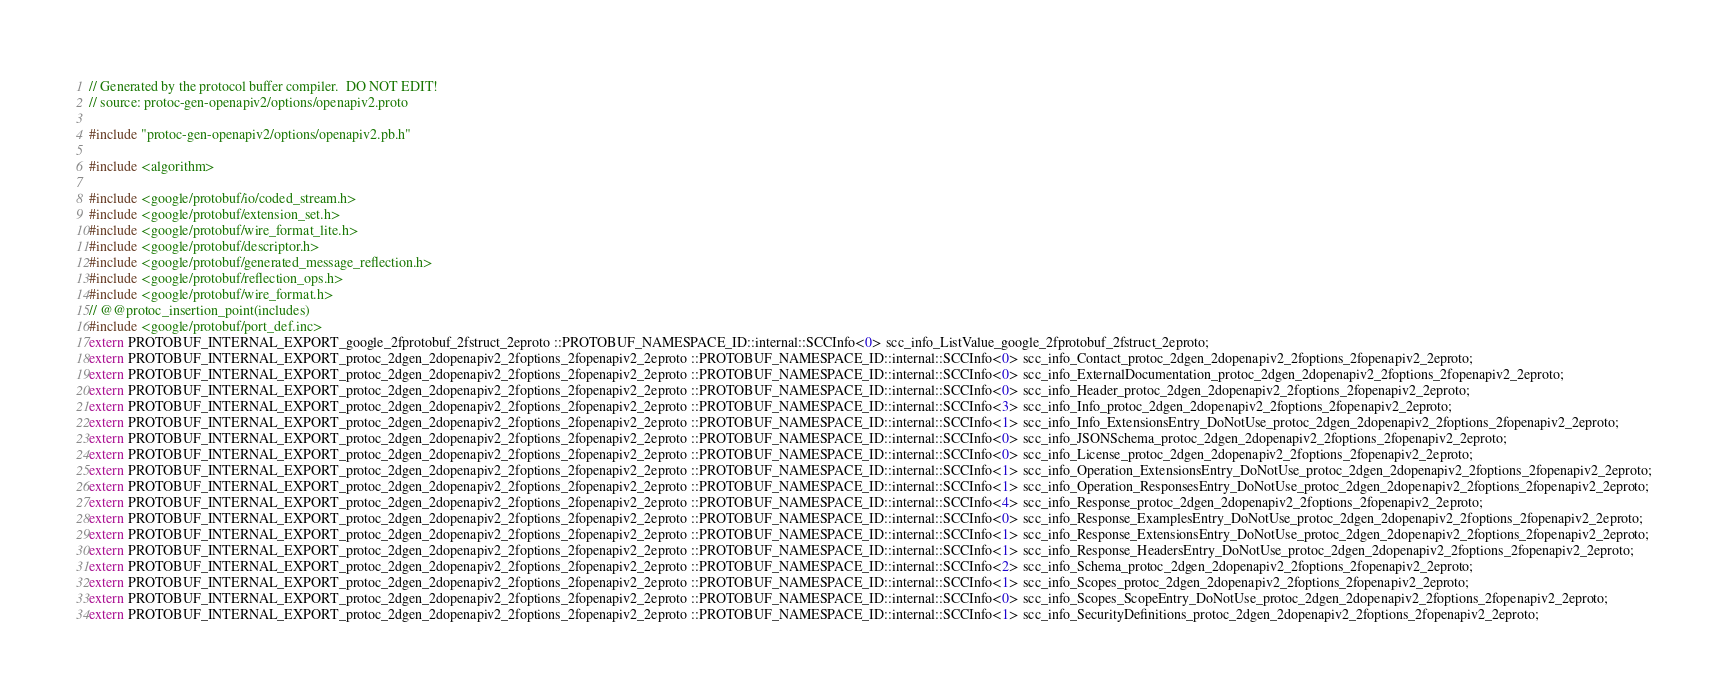<code> <loc_0><loc_0><loc_500><loc_500><_C++_>// Generated by the protocol buffer compiler.  DO NOT EDIT!
// source: protoc-gen-openapiv2/options/openapiv2.proto

#include "protoc-gen-openapiv2/options/openapiv2.pb.h"

#include <algorithm>

#include <google/protobuf/io/coded_stream.h>
#include <google/protobuf/extension_set.h>
#include <google/protobuf/wire_format_lite.h>
#include <google/protobuf/descriptor.h>
#include <google/protobuf/generated_message_reflection.h>
#include <google/protobuf/reflection_ops.h>
#include <google/protobuf/wire_format.h>
// @@protoc_insertion_point(includes)
#include <google/protobuf/port_def.inc>
extern PROTOBUF_INTERNAL_EXPORT_google_2fprotobuf_2fstruct_2eproto ::PROTOBUF_NAMESPACE_ID::internal::SCCInfo<0> scc_info_ListValue_google_2fprotobuf_2fstruct_2eproto;
extern PROTOBUF_INTERNAL_EXPORT_protoc_2dgen_2dopenapiv2_2foptions_2fopenapiv2_2eproto ::PROTOBUF_NAMESPACE_ID::internal::SCCInfo<0> scc_info_Contact_protoc_2dgen_2dopenapiv2_2foptions_2fopenapiv2_2eproto;
extern PROTOBUF_INTERNAL_EXPORT_protoc_2dgen_2dopenapiv2_2foptions_2fopenapiv2_2eproto ::PROTOBUF_NAMESPACE_ID::internal::SCCInfo<0> scc_info_ExternalDocumentation_protoc_2dgen_2dopenapiv2_2foptions_2fopenapiv2_2eproto;
extern PROTOBUF_INTERNAL_EXPORT_protoc_2dgen_2dopenapiv2_2foptions_2fopenapiv2_2eproto ::PROTOBUF_NAMESPACE_ID::internal::SCCInfo<0> scc_info_Header_protoc_2dgen_2dopenapiv2_2foptions_2fopenapiv2_2eproto;
extern PROTOBUF_INTERNAL_EXPORT_protoc_2dgen_2dopenapiv2_2foptions_2fopenapiv2_2eproto ::PROTOBUF_NAMESPACE_ID::internal::SCCInfo<3> scc_info_Info_protoc_2dgen_2dopenapiv2_2foptions_2fopenapiv2_2eproto;
extern PROTOBUF_INTERNAL_EXPORT_protoc_2dgen_2dopenapiv2_2foptions_2fopenapiv2_2eproto ::PROTOBUF_NAMESPACE_ID::internal::SCCInfo<1> scc_info_Info_ExtensionsEntry_DoNotUse_protoc_2dgen_2dopenapiv2_2foptions_2fopenapiv2_2eproto;
extern PROTOBUF_INTERNAL_EXPORT_protoc_2dgen_2dopenapiv2_2foptions_2fopenapiv2_2eproto ::PROTOBUF_NAMESPACE_ID::internal::SCCInfo<0> scc_info_JSONSchema_protoc_2dgen_2dopenapiv2_2foptions_2fopenapiv2_2eproto;
extern PROTOBUF_INTERNAL_EXPORT_protoc_2dgen_2dopenapiv2_2foptions_2fopenapiv2_2eproto ::PROTOBUF_NAMESPACE_ID::internal::SCCInfo<0> scc_info_License_protoc_2dgen_2dopenapiv2_2foptions_2fopenapiv2_2eproto;
extern PROTOBUF_INTERNAL_EXPORT_protoc_2dgen_2dopenapiv2_2foptions_2fopenapiv2_2eproto ::PROTOBUF_NAMESPACE_ID::internal::SCCInfo<1> scc_info_Operation_ExtensionsEntry_DoNotUse_protoc_2dgen_2dopenapiv2_2foptions_2fopenapiv2_2eproto;
extern PROTOBUF_INTERNAL_EXPORT_protoc_2dgen_2dopenapiv2_2foptions_2fopenapiv2_2eproto ::PROTOBUF_NAMESPACE_ID::internal::SCCInfo<1> scc_info_Operation_ResponsesEntry_DoNotUse_protoc_2dgen_2dopenapiv2_2foptions_2fopenapiv2_2eproto;
extern PROTOBUF_INTERNAL_EXPORT_protoc_2dgen_2dopenapiv2_2foptions_2fopenapiv2_2eproto ::PROTOBUF_NAMESPACE_ID::internal::SCCInfo<4> scc_info_Response_protoc_2dgen_2dopenapiv2_2foptions_2fopenapiv2_2eproto;
extern PROTOBUF_INTERNAL_EXPORT_protoc_2dgen_2dopenapiv2_2foptions_2fopenapiv2_2eproto ::PROTOBUF_NAMESPACE_ID::internal::SCCInfo<0> scc_info_Response_ExamplesEntry_DoNotUse_protoc_2dgen_2dopenapiv2_2foptions_2fopenapiv2_2eproto;
extern PROTOBUF_INTERNAL_EXPORT_protoc_2dgen_2dopenapiv2_2foptions_2fopenapiv2_2eproto ::PROTOBUF_NAMESPACE_ID::internal::SCCInfo<1> scc_info_Response_ExtensionsEntry_DoNotUse_protoc_2dgen_2dopenapiv2_2foptions_2fopenapiv2_2eproto;
extern PROTOBUF_INTERNAL_EXPORT_protoc_2dgen_2dopenapiv2_2foptions_2fopenapiv2_2eproto ::PROTOBUF_NAMESPACE_ID::internal::SCCInfo<1> scc_info_Response_HeadersEntry_DoNotUse_protoc_2dgen_2dopenapiv2_2foptions_2fopenapiv2_2eproto;
extern PROTOBUF_INTERNAL_EXPORT_protoc_2dgen_2dopenapiv2_2foptions_2fopenapiv2_2eproto ::PROTOBUF_NAMESPACE_ID::internal::SCCInfo<2> scc_info_Schema_protoc_2dgen_2dopenapiv2_2foptions_2fopenapiv2_2eproto;
extern PROTOBUF_INTERNAL_EXPORT_protoc_2dgen_2dopenapiv2_2foptions_2fopenapiv2_2eproto ::PROTOBUF_NAMESPACE_ID::internal::SCCInfo<1> scc_info_Scopes_protoc_2dgen_2dopenapiv2_2foptions_2fopenapiv2_2eproto;
extern PROTOBUF_INTERNAL_EXPORT_protoc_2dgen_2dopenapiv2_2foptions_2fopenapiv2_2eproto ::PROTOBUF_NAMESPACE_ID::internal::SCCInfo<0> scc_info_Scopes_ScopeEntry_DoNotUse_protoc_2dgen_2dopenapiv2_2foptions_2fopenapiv2_2eproto;
extern PROTOBUF_INTERNAL_EXPORT_protoc_2dgen_2dopenapiv2_2foptions_2fopenapiv2_2eproto ::PROTOBUF_NAMESPACE_ID::internal::SCCInfo<1> scc_info_SecurityDefinitions_protoc_2dgen_2dopenapiv2_2foptions_2fopenapiv2_2eproto;</code> 